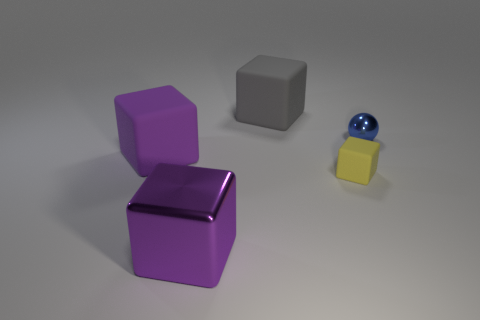Subtract all rubber blocks. How many blocks are left? 1 Add 1 large cyan matte objects. How many objects exist? 6 Subtract all gray cubes. How many cubes are left? 3 Subtract all blocks. How many objects are left? 1 Subtract 2 blocks. How many blocks are left? 2 Subtract all yellow cylinders. How many purple blocks are left? 2 Subtract all yellow balls. Subtract all red cylinders. How many balls are left? 1 Subtract all tiny red things. Subtract all metal objects. How many objects are left? 3 Add 2 large purple metallic cubes. How many large purple metallic cubes are left? 3 Add 1 big brown matte cylinders. How many big brown matte cylinders exist? 1 